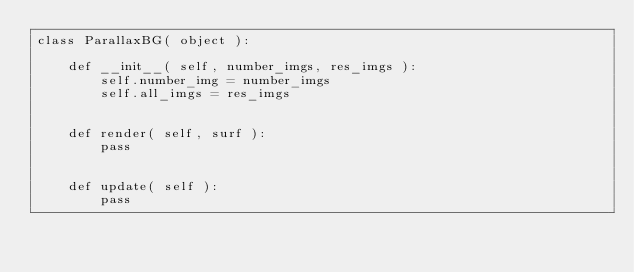Convert code to text. <code><loc_0><loc_0><loc_500><loc_500><_Python_>class ParallaxBG( object ):

    def __init__( self, number_imgs, res_imgs ):
        self.number_img = number_imgs
        self.all_imgs = res_imgs


    def render( self, surf ):
        pass


    def update( self ):
        pass
</code> 